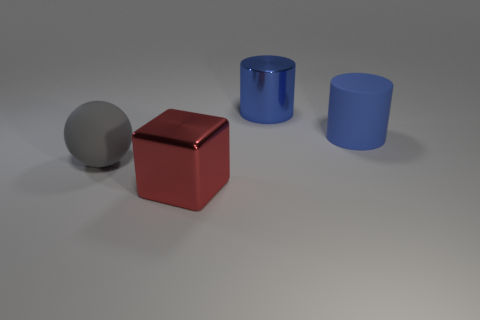Subtract all balls. How many objects are left? 3 Add 2 red cylinders. How many objects exist? 6 Add 1 cubes. How many cubes are left? 2 Add 1 big gray objects. How many big gray objects exist? 2 Subtract 0 yellow cubes. How many objects are left? 4 Subtract 1 blocks. How many blocks are left? 0 Subtract all cyan cylinders. Subtract all blue spheres. How many cylinders are left? 2 Subtract all red cylinders. How many yellow balls are left? 0 Subtract all green matte cubes. Subtract all big shiny objects. How many objects are left? 2 